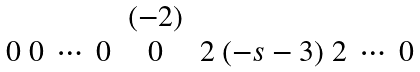Convert formula to latex. <formula><loc_0><loc_0><loc_500><loc_500>\begin{matrix} & ( - 2 ) & \\ 0 \ 0 \ \cdots \ 0 & 0 & 2 \ ( - s - 3 ) \ 2 \ \cdots \ 0 \end{matrix}</formula> 